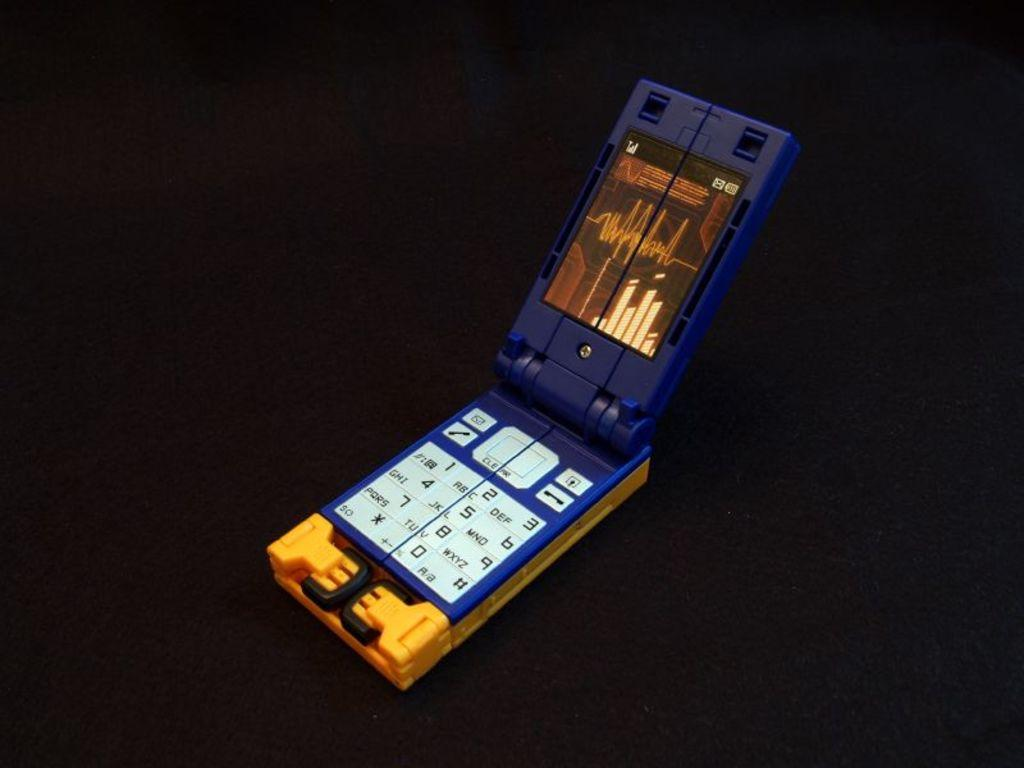<image>
Share a concise interpretation of the image provided. a pretend flip phone with the numbers 1-0 on it 